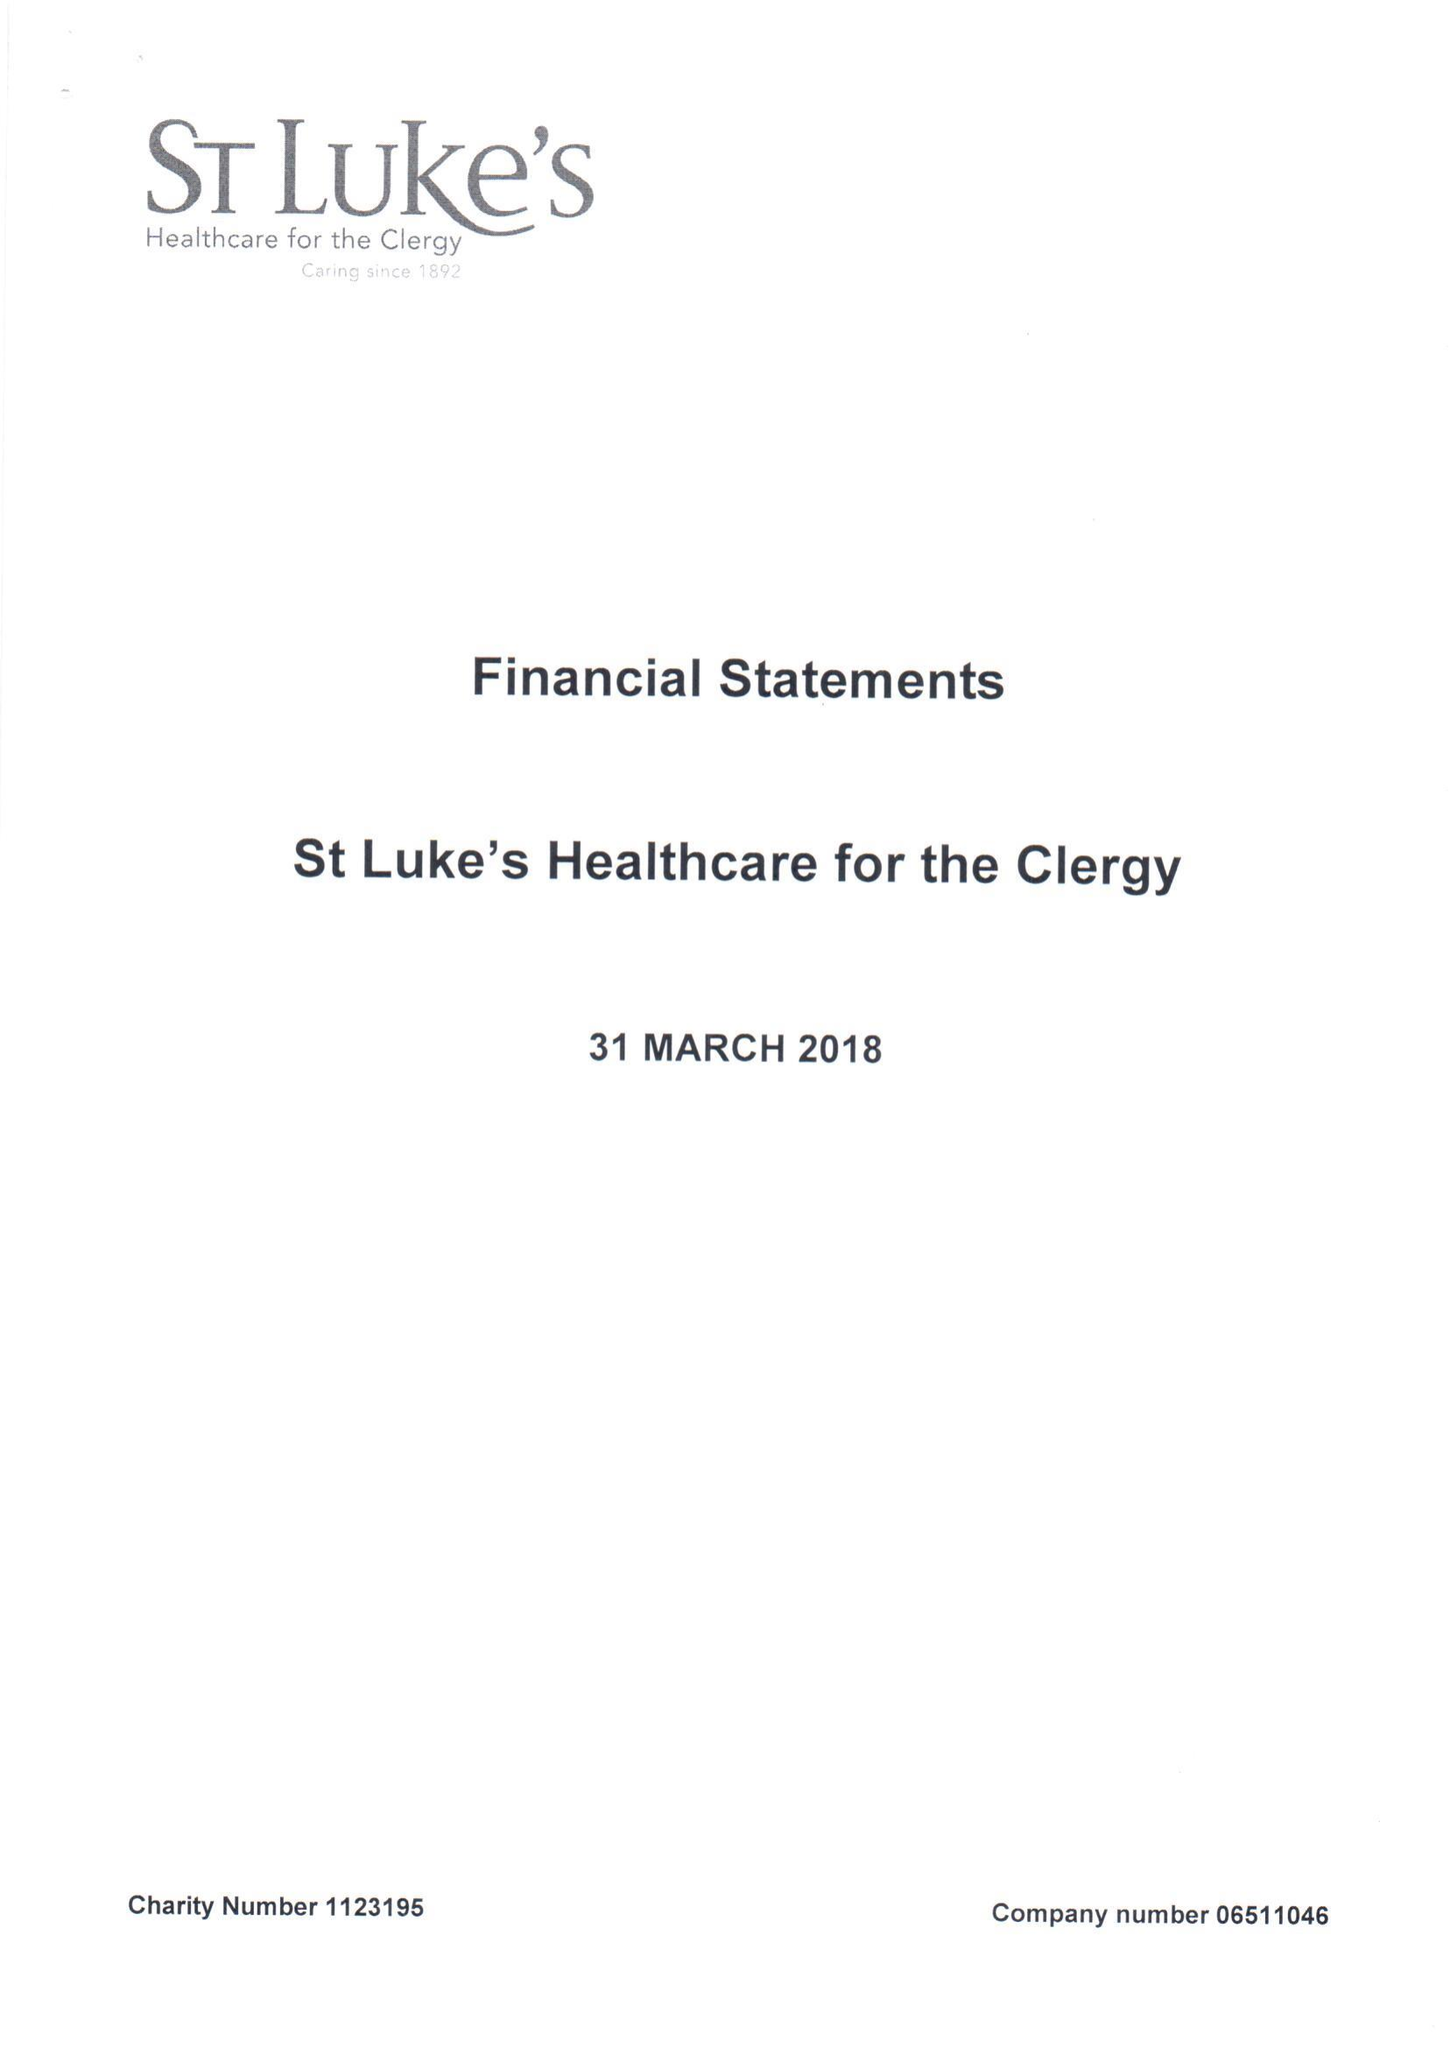What is the value for the address__street_line?
Answer the question using a single word or phrase. 27 GREAT SMITH STREET 